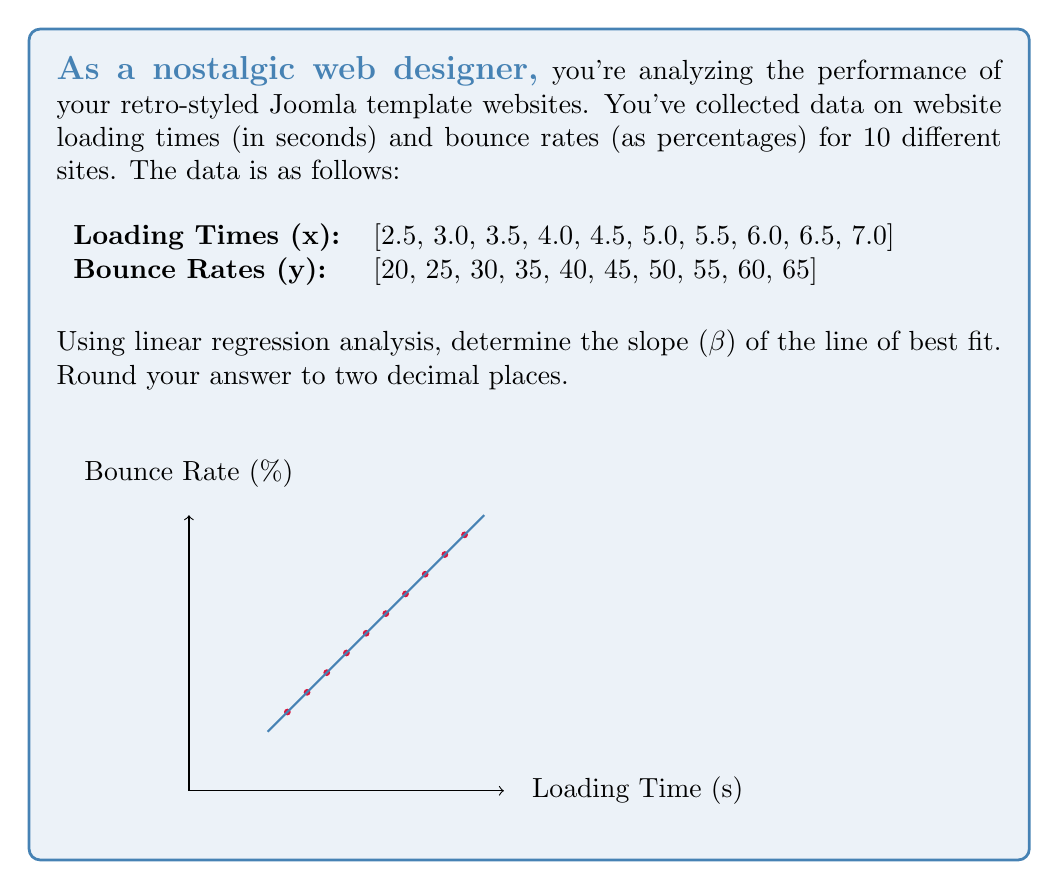Can you answer this question? To find the slope (β) of the line of best fit using linear regression, we'll use the formula:

$$ \beta = \frac{n\sum xy - \sum x \sum y}{n\sum x^2 - (\sum x)^2} $$

Where n is the number of data points, x is the loading time, and y is the bounce rate.

Step 1: Calculate the required sums:
n = 10
$\sum x = 47.5$
$\sum y = 425$
$\sum xy = 2237.5$
$\sum x^2 = 247.75$
$(\sum x)^2 = 2256.25$

Step 2: Plug these values into the formula:

$$ \beta = \frac{10(2237.5) - (47.5)(425)}{10(247.75) - (2256.25)} $$

Step 3: Simplify:

$$ \beta = \frac{22375 - 20187.5}{2477.5 - 2256.25} $$

$$ \beta = \frac{2187.5}{221.25} $$

Step 4: Calculate and round to two decimal places:

$$ \beta = 9.89 $$

This slope indicates that for every 1-second increase in loading time, the bounce rate increases by approximately 9.89 percentage points.
Answer: 9.89 